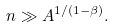Convert formula to latex. <formula><loc_0><loc_0><loc_500><loc_500>n \gg A ^ { 1 / ( 1 - \beta ) } .</formula> 